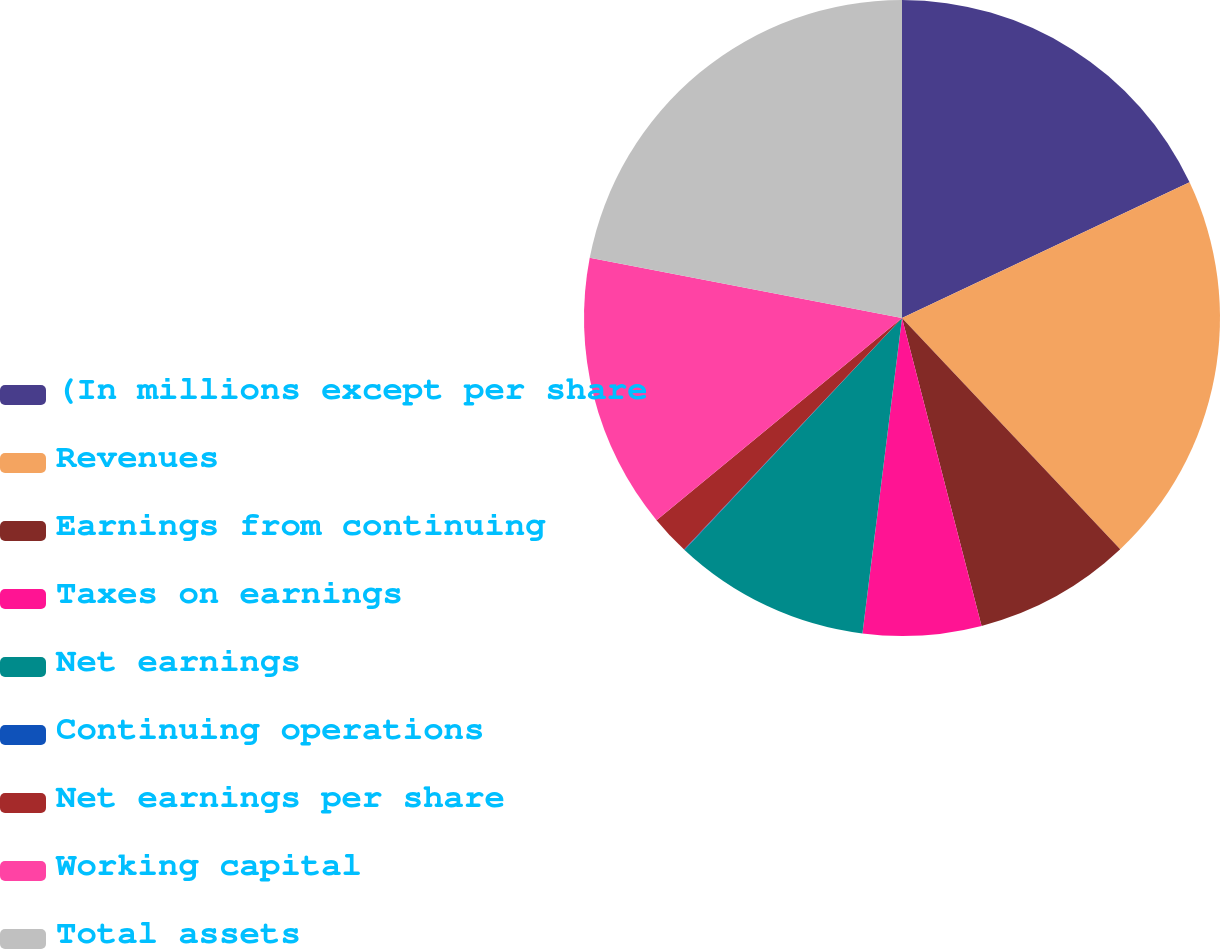Convert chart to OTSL. <chart><loc_0><loc_0><loc_500><loc_500><pie_chart><fcel>(In millions except per share<fcel>Revenues<fcel>Earnings from continuing<fcel>Taxes on earnings<fcel>Net earnings<fcel>Continuing operations<fcel>Net earnings per share<fcel>Working capital<fcel>Total assets<nl><fcel>17.98%<fcel>19.98%<fcel>8.01%<fcel>6.01%<fcel>10.0%<fcel>0.03%<fcel>2.02%<fcel>13.99%<fcel>21.97%<nl></chart> 